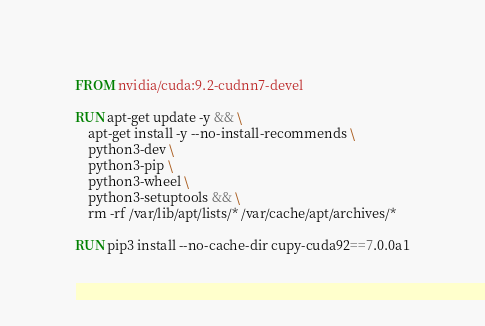<code> <loc_0><loc_0><loc_500><loc_500><_Dockerfile_>FROM nvidia/cuda:9.2-cudnn7-devel

RUN apt-get update -y && \
    apt-get install -y --no-install-recommends \
    python3-dev \
    python3-pip \
    python3-wheel \
    python3-setuptools && \
    rm -rf /var/lib/apt/lists/* /var/cache/apt/archives/*

RUN pip3 install --no-cache-dir cupy-cuda92==7.0.0a1
</code> 